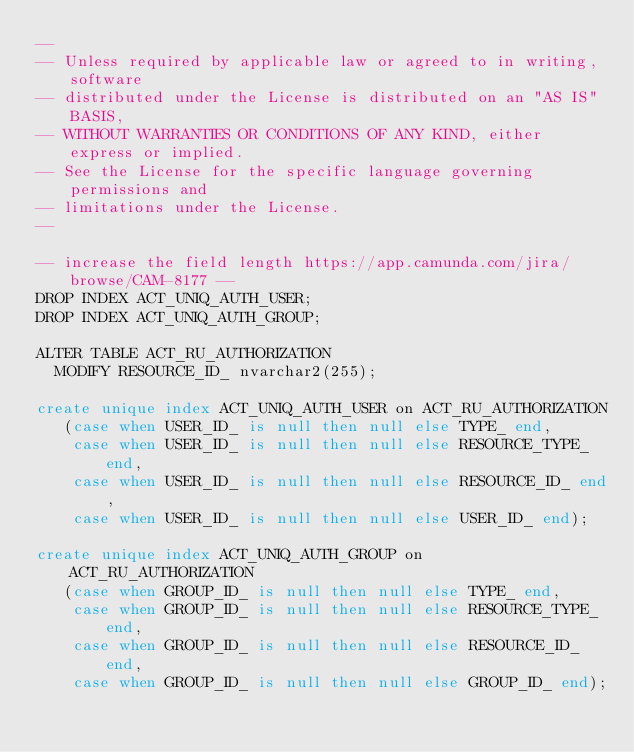Convert code to text. <code><loc_0><loc_0><loc_500><loc_500><_SQL_>--
-- Unless required by applicable law or agreed to in writing, software
-- distributed under the License is distributed on an "AS IS" BASIS,
-- WITHOUT WARRANTIES OR CONDITIONS OF ANY KIND, either express or implied.
-- See the License for the specific language governing permissions and
-- limitations under the License.
--

-- increase the field length https://app.camunda.com/jira/browse/CAM-8177 --
DROP INDEX ACT_UNIQ_AUTH_USER;
DROP INDEX ACT_UNIQ_AUTH_GROUP;

ALTER TABLE ACT_RU_AUTHORIZATION 
  MODIFY RESOURCE_ID_ nvarchar2(255);

create unique index ACT_UNIQ_AUTH_USER on ACT_RU_AUTHORIZATION
   (case when USER_ID_ is null then null else TYPE_ end,
    case when USER_ID_ is null then null else RESOURCE_TYPE_ end,
    case when USER_ID_ is null then null else RESOURCE_ID_ end,
    case when USER_ID_ is null then null else USER_ID_ end);

create unique index ACT_UNIQ_AUTH_GROUP on ACT_RU_AUTHORIZATION
   (case when GROUP_ID_ is null then null else TYPE_ end,
    case when GROUP_ID_ is null then null else RESOURCE_TYPE_ end,
    case when GROUP_ID_ is null then null else RESOURCE_ID_ end,
    case when GROUP_ID_ is null then null else GROUP_ID_ end);
</code> 